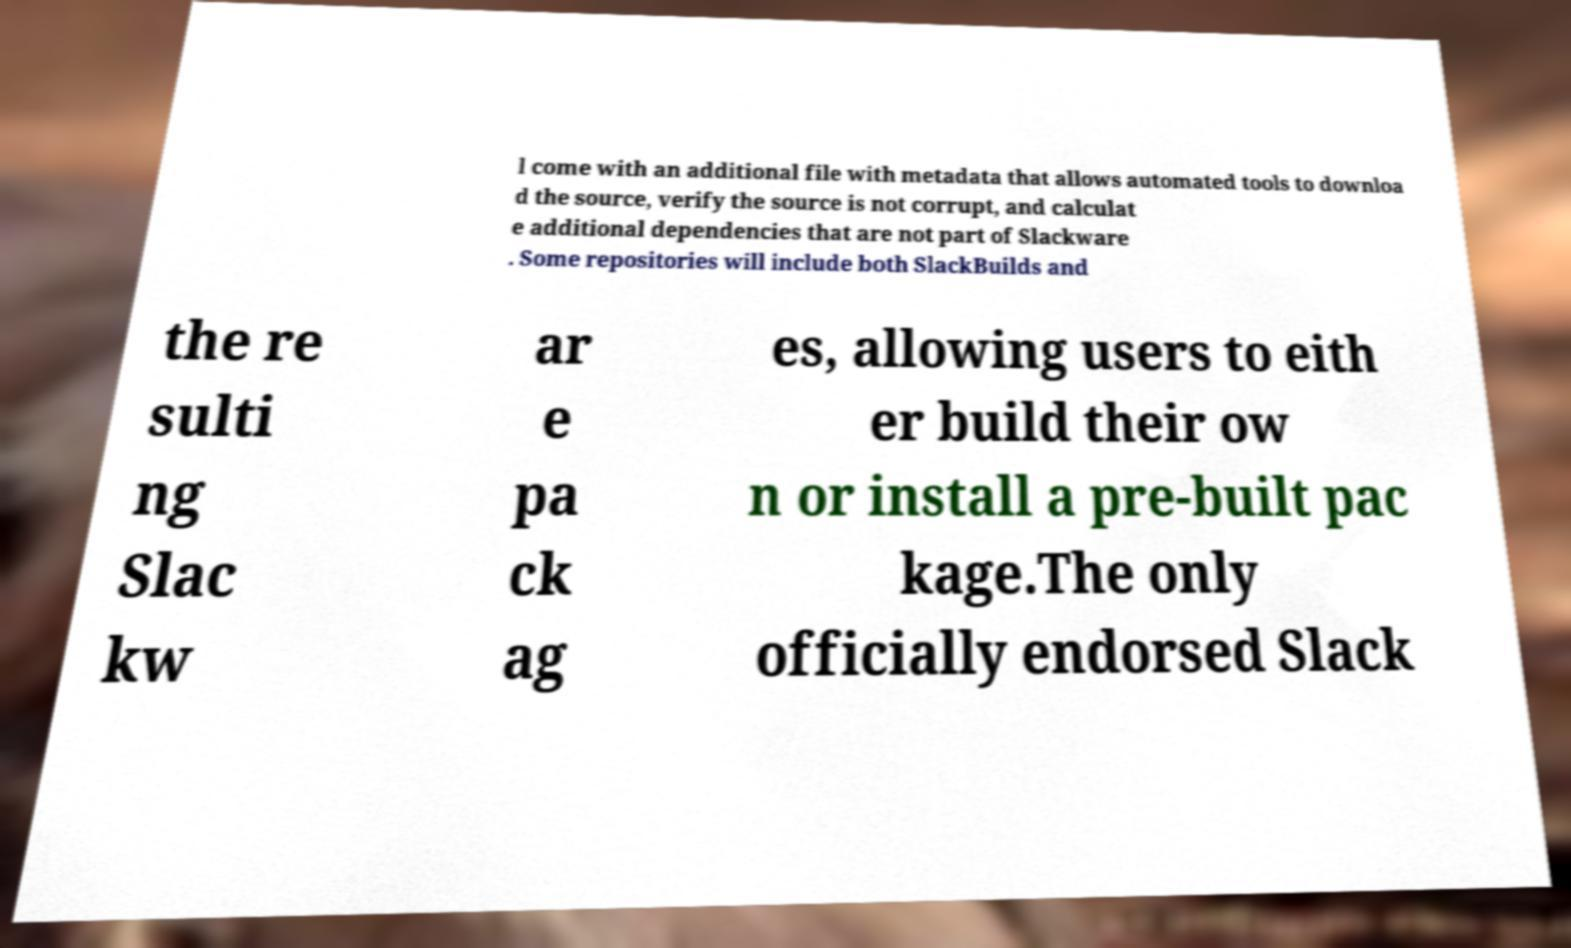What messages or text are displayed in this image? I need them in a readable, typed format. l come with an additional file with metadata that allows automated tools to downloa d the source, verify the source is not corrupt, and calculat e additional dependencies that are not part of Slackware . Some repositories will include both SlackBuilds and the re sulti ng Slac kw ar e pa ck ag es, allowing users to eith er build their ow n or install a pre-built pac kage.The only officially endorsed Slack 